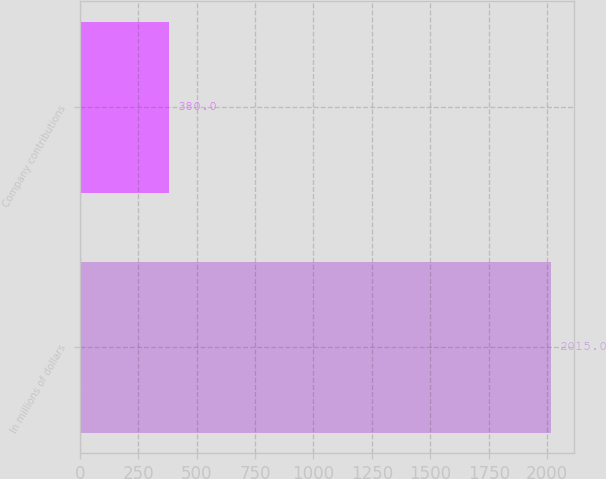<chart> <loc_0><loc_0><loc_500><loc_500><bar_chart><fcel>In millions of dollars<fcel>Company contributions<nl><fcel>2015<fcel>380<nl></chart> 